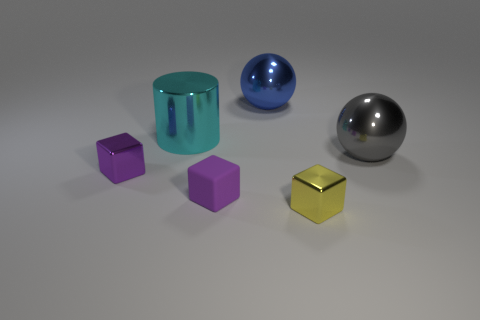Subtract all yellow balls. Subtract all yellow cylinders. How many balls are left? 2 Add 1 cylinders. How many objects exist? 7 Subtract all cylinders. How many objects are left? 5 Subtract 0 red cubes. How many objects are left? 6 Subtract all small brown cylinders. Subtract all cyan objects. How many objects are left? 5 Add 4 tiny rubber blocks. How many tiny rubber blocks are left? 5 Add 1 matte blocks. How many matte blocks exist? 2 